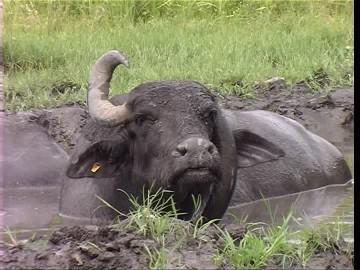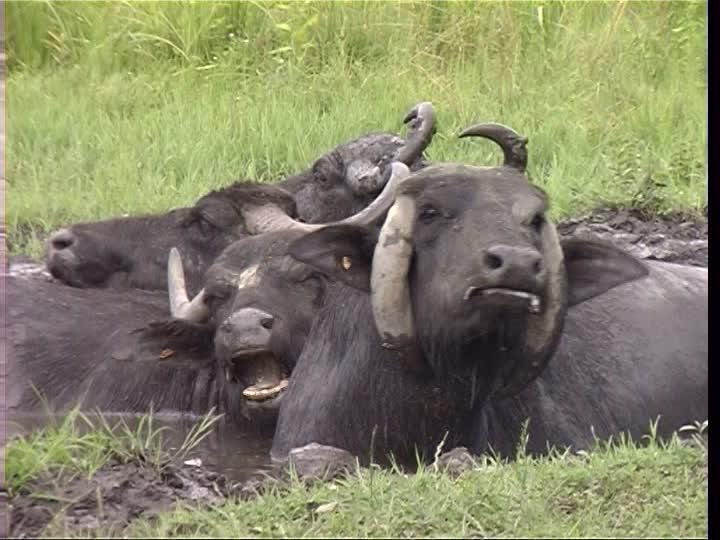The first image is the image on the left, the second image is the image on the right. Examine the images to the left and right. Is the description "At least one cow is standing chest deep in water." accurate? Answer yes or no. Yes. 